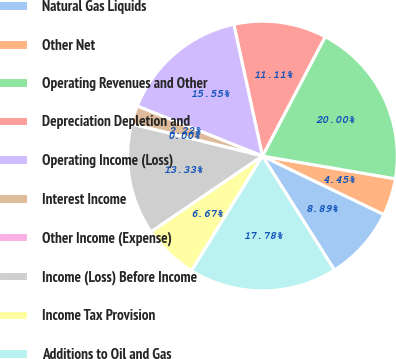Convert chart to OTSL. <chart><loc_0><loc_0><loc_500><loc_500><pie_chart><fcel>Natural Gas Liquids<fcel>Other Net<fcel>Operating Revenues and Other<fcel>Depreciation Depletion and<fcel>Operating Income (Loss)<fcel>Interest Income<fcel>Other Income (Expense)<fcel>Income (Loss) Before Income<fcel>Income Tax Provision<fcel>Additions to Oil and Gas<nl><fcel>8.89%<fcel>4.45%<fcel>20.0%<fcel>11.11%<fcel>15.55%<fcel>2.22%<fcel>0.0%<fcel>13.33%<fcel>6.67%<fcel>17.78%<nl></chart> 